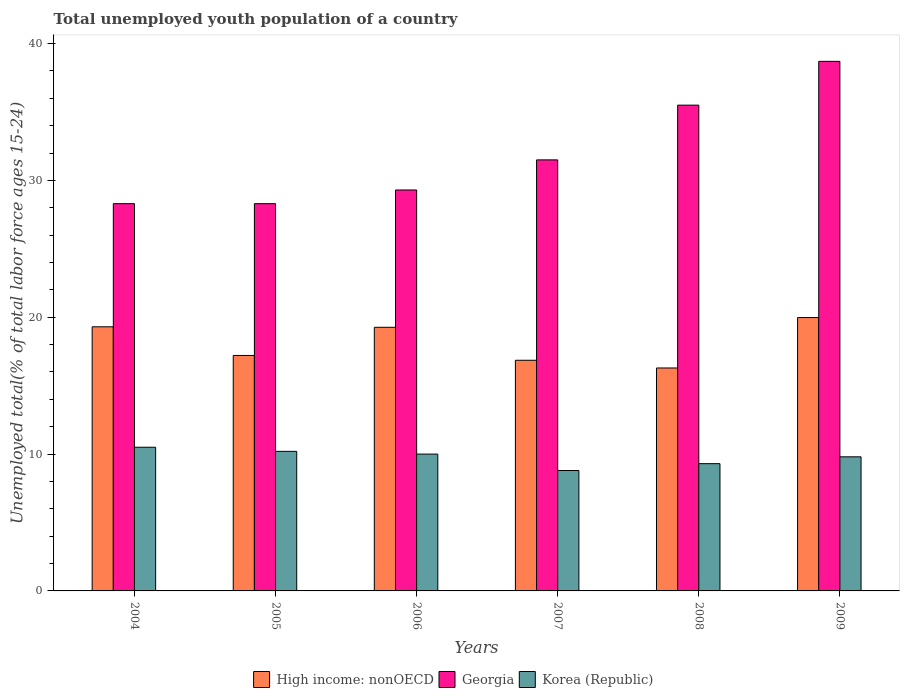How many different coloured bars are there?
Offer a terse response. 3. How many groups of bars are there?
Your response must be concise. 6. Are the number of bars on each tick of the X-axis equal?
Keep it short and to the point. Yes. How many bars are there on the 5th tick from the left?
Your response must be concise. 3. In how many cases, is the number of bars for a given year not equal to the number of legend labels?
Your answer should be compact. 0. What is the percentage of total unemployed youth population of a country in High income: nonOECD in 2007?
Your response must be concise. 16.86. Across all years, what is the maximum percentage of total unemployed youth population of a country in High income: nonOECD?
Ensure brevity in your answer.  19.98. Across all years, what is the minimum percentage of total unemployed youth population of a country in High income: nonOECD?
Provide a succinct answer. 16.29. In which year was the percentage of total unemployed youth population of a country in Korea (Republic) maximum?
Provide a short and direct response. 2004. In which year was the percentage of total unemployed youth population of a country in Korea (Republic) minimum?
Your answer should be compact. 2007. What is the total percentage of total unemployed youth population of a country in Georgia in the graph?
Keep it short and to the point. 191.6. What is the difference between the percentage of total unemployed youth population of a country in Korea (Republic) in 2006 and that in 2007?
Keep it short and to the point. 1.2. What is the difference between the percentage of total unemployed youth population of a country in Georgia in 2007 and the percentage of total unemployed youth population of a country in Korea (Republic) in 2008?
Your answer should be compact. 22.2. What is the average percentage of total unemployed youth population of a country in High income: nonOECD per year?
Your answer should be very brief. 18.15. In the year 2005, what is the difference between the percentage of total unemployed youth population of a country in Georgia and percentage of total unemployed youth population of a country in High income: nonOECD?
Keep it short and to the point. 11.09. In how many years, is the percentage of total unemployed youth population of a country in High income: nonOECD greater than 12 %?
Keep it short and to the point. 6. What is the ratio of the percentage of total unemployed youth population of a country in Korea (Republic) in 2004 to that in 2008?
Provide a succinct answer. 1.13. Is the percentage of total unemployed youth population of a country in Korea (Republic) in 2005 less than that in 2008?
Offer a very short reply. No. Is the difference between the percentage of total unemployed youth population of a country in Georgia in 2005 and 2006 greater than the difference between the percentage of total unemployed youth population of a country in High income: nonOECD in 2005 and 2006?
Your answer should be very brief. Yes. What is the difference between the highest and the second highest percentage of total unemployed youth population of a country in Korea (Republic)?
Your answer should be compact. 0.3. What is the difference between the highest and the lowest percentage of total unemployed youth population of a country in High income: nonOECD?
Ensure brevity in your answer.  3.69. Is the sum of the percentage of total unemployed youth population of a country in Korea (Republic) in 2005 and 2006 greater than the maximum percentage of total unemployed youth population of a country in High income: nonOECD across all years?
Give a very brief answer. Yes. What does the 3rd bar from the left in 2008 represents?
Provide a short and direct response. Korea (Republic). What does the 1st bar from the right in 2006 represents?
Keep it short and to the point. Korea (Republic). How many bars are there?
Ensure brevity in your answer.  18. Are all the bars in the graph horizontal?
Ensure brevity in your answer.  No. How many years are there in the graph?
Your answer should be compact. 6. Where does the legend appear in the graph?
Your answer should be compact. Bottom center. How many legend labels are there?
Give a very brief answer. 3. How are the legend labels stacked?
Offer a very short reply. Horizontal. What is the title of the graph?
Your answer should be compact. Total unemployed youth population of a country. What is the label or title of the X-axis?
Provide a succinct answer. Years. What is the label or title of the Y-axis?
Keep it short and to the point. Unemployed total(% of total labor force ages 15-24). What is the Unemployed total(% of total labor force ages 15-24) of High income: nonOECD in 2004?
Your answer should be compact. 19.3. What is the Unemployed total(% of total labor force ages 15-24) in Georgia in 2004?
Provide a succinct answer. 28.3. What is the Unemployed total(% of total labor force ages 15-24) in Korea (Republic) in 2004?
Offer a very short reply. 10.5. What is the Unemployed total(% of total labor force ages 15-24) in High income: nonOECD in 2005?
Provide a succinct answer. 17.21. What is the Unemployed total(% of total labor force ages 15-24) in Georgia in 2005?
Make the answer very short. 28.3. What is the Unemployed total(% of total labor force ages 15-24) of Korea (Republic) in 2005?
Make the answer very short. 10.2. What is the Unemployed total(% of total labor force ages 15-24) in High income: nonOECD in 2006?
Your answer should be compact. 19.27. What is the Unemployed total(% of total labor force ages 15-24) of Georgia in 2006?
Give a very brief answer. 29.3. What is the Unemployed total(% of total labor force ages 15-24) in Korea (Republic) in 2006?
Give a very brief answer. 10. What is the Unemployed total(% of total labor force ages 15-24) of High income: nonOECD in 2007?
Ensure brevity in your answer.  16.86. What is the Unemployed total(% of total labor force ages 15-24) in Georgia in 2007?
Keep it short and to the point. 31.5. What is the Unemployed total(% of total labor force ages 15-24) of Korea (Republic) in 2007?
Offer a terse response. 8.8. What is the Unemployed total(% of total labor force ages 15-24) of High income: nonOECD in 2008?
Offer a terse response. 16.29. What is the Unemployed total(% of total labor force ages 15-24) in Georgia in 2008?
Your answer should be very brief. 35.5. What is the Unemployed total(% of total labor force ages 15-24) of Korea (Republic) in 2008?
Make the answer very short. 9.3. What is the Unemployed total(% of total labor force ages 15-24) of High income: nonOECD in 2009?
Your answer should be compact. 19.98. What is the Unemployed total(% of total labor force ages 15-24) in Georgia in 2009?
Keep it short and to the point. 38.7. What is the Unemployed total(% of total labor force ages 15-24) of Korea (Republic) in 2009?
Offer a very short reply. 9.8. Across all years, what is the maximum Unemployed total(% of total labor force ages 15-24) in High income: nonOECD?
Offer a terse response. 19.98. Across all years, what is the maximum Unemployed total(% of total labor force ages 15-24) in Georgia?
Provide a succinct answer. 38.7. Across all years, what is the maximum Unemployed total(% of total labor force ages 15-24) in Korea (Republic)?
Keep it short and to the point. 10.5. Across all years, what is the minimum Unemployed total(% of total labor force ages 15-24) in High income: nonOECD?
Provide a succinct answer. 16.29. Across all years, what is the minimum Unemployed total(% of total labor force ages 15-24) in Georgia?
Your answer should be very brief. 28.3. Across all years, what is the minimum Unemployed total(% of total labor force ages 15-24) in Korea (Republic)?
Your answer should be very brief. 8.8. What is the total Unemployed total(% of total labor force ages 15-24) of High income: nonOECD in the graph?
Your answer should be very brief. 108.9. What is the total Unemployed total(% of total labor force ages 15-24) of Georgia in the graph?
Your response must be concise. 191.6. What is the total Unemployed total(% of total labor force ages 15-24) of Korea (Republic) in the graph?
Give a very brief answer. 58.6. What is the difference between the Unemployed total(% of total labor force ages 15-24) of High income: nonOECD in 2004 and that in 2005?
Offer a terse response. 2.09. What is the difference between the Unemployed total(% of total labor force ages 15-24) of Korea (Republic) in 2004 and that in 2005?
Provide a succinct answer. 0.3. What is the difference between the Unemployed total(% of total labor force ages 15-24) in High income: nonOECD in 2004 and that in 2006?
Provide a succinct answer. 0.04. What is the difference between the Unemployed total(% of total labor force ages 15-24) in Georgia in 2004 and that in 2006?
Keep it short and to the point. -1. What is the difference between the Unemployed total(% of total labor force ages 15-24) of High income: nonOECD in 2004 and that in 2007?
Give a very brief answer. 2.45. What is the difference between the Unemployed total(% of total labor force ages 15-24) in Georgia in 2004 and that in 2007?
Ensure brevity in your answer.  -3.2. What is the difference between the Unemployed total(% of total labor force ages 15-24) in Korea (Republic) in 2004 and that in 2007?
Give a very brief answer. 1.7. What is the difference between the Unemployed total(% of total labor force ages 15-24) in High income: nonOECD in 2004 and that in 2008?
Offer a terse response. 3.01. What is the difference between the Unemployed total(% of total labor force ages 15-24) in High income: nonOECD in 2004 and that in 2009?
Your answer should be very brief. -0.67. What is the difference between the Unemployed total(% of total labor force ages 15-24) in Georgia in 2004 and that in 2009?
Give a very brief answer. -10.4. What is the difference between the Unemployed total(% of total labor force ages 15-24) in High income: nonOECD in 2005 and that in 2006?
Provide a short and direct response. -2.06. What is the difference between the Unemployed total(% of total labor force ages 15-24) of High income: nonOECD in 2005 and that in 2007?
Ensure brevity in your answer.  0.35. What is the difference between the Unemployed total(% of total labor force ages 15-24) in High income: nonOECD in 2005 and that in 2008?
Your response must be concise. 0.92. What is the difference between the Unemployed total(% of total labor force ages 15-24) in Georgia in 2005 and that in 2008?
Your answer should be very brief. -7.2. What is the difference between the Unemployed total(% of total labor force ages 15-24) of Korea (Republic) in 2005 and that in 2008?
Your answer should be compact. 0.9. What is the difference between the Unemployed total(% of total labor force ages 15-24) in High income: nonOECD in 2005 and that in 2009?
Your answer should be compact. -2.77. What is the difference between the Unemployed total(% of total labor force ages 15-24) in Korea (Republic) in 2005 and that in 2009?
Ensure brevity in your answer.  0.4. What is the difference between the Unemployed total(% of total labor force ages 15-24) in High income: nonOECD in 2006 and that in 2007?
Your response must be concise. 2.41. What is the difference between the Unemployed total(% of total labor force ages 15-24) in Georgia in 2006 and that in 2007?
Keep it short and to the point. -2.2. What is the difference between the Unemployed total(% of total labor force ages 15-24) of Korea (Republic) in 2006 and that in 2007?
Offer a terse response. 1.2. What is the difference between the Unemployed total(% of total labor force ages 15-24) of High income: nonOECD in 2006 and that in 2008?
Keep it short and to the point. 2.97. What is the difference between the Unemployed total(% of total labor force ages 15-24) of Georgia in 2006 and that in 2008?
Your response must be concise. -6.2. What is the difference between the Unemployed total(% of total labor force ages 15-24) of High income: nonOECD in 2006 and that in 2009?
Provide a succinct answer. -0.71. What is the difference between the Unemployed total(% of total labor force ages 15-24) in Georgia in 2006 and that in 2009?
Provide a short and direct response. -9.4. What is the difference between the Unemployed total(% of total labor force ages 15-24) in High income: nonOECD in 2007 and that in 2008?
Ensure brevity in your answer.  0.56. What is the difference between the Unemployed total(% of total labor force ages 15-24) in Korea (Republic) in 2007 and that in 2008?
Your response must be concise. -0.5. What is the difference between the Unemployed total(% of total labor force ages 15-24) in High income: nonOECD in 2007 and that in 2009?
Keep it short and to the point. -3.12. What is the difference between the Unemployed total(% of total labor force ages 15-24) of High income: nonOECD in 2008 and that in 2009?
Your response must be concise. -3.69. What is the difference between the Unemployed total(% of total labor force ages 15-24) of Georgia in 2008 and that in 2009?
Offer a very short reply. -3.2. What is the difference between the Unemployed total(% of total labor force ages 15-24) in Korea (Republic) in 2008 and that in 2009?
Make the answer very short. -0.5. What is the difference between the Unemployed total(% of total labor force ages 15-24) in High income: nonOECD in 2004 and the Unemployed total(% of total labor force ages 15-24) in Georgia in 2005?
Offer a terse response. -9. What is the difference between the Unemployed total(% of total labor force ages 15-24) of High income: nonOECD in 2004 and the Unemployed total(% of total labor force ages 15-24) of Korea (Republic) in 2005?
Make the answer very short. 9.1. What is the difference between the Unemployed total(% of total labor force ages 15-24) in Georgia in 2004 and the Unemployed total(% of total labor force ages 15-24) in Korea (Republic) in 2005?
Ensure brevity in your answer.  18.1. What is the difference between the Unemployed total(% of total labor force ages 15-24) of High income: nonOECD in 2004 and the Unemployed total(% of total labor force ages 15-24) of Georgia in 2006?
Your answer should be compact. -10. What is the difference between the Unemployed total(% of total labor force ages 15-24) of High income: nonOECD in 2004 and the Unemployed total(% of total labor force ages 15-24) of Korea (Republic) in 2006?
Your answer should be compact. 9.3. What is the difference between the Unemployed total(% of total labor force ages 15-24) of High income: nonOECD in 2004 and the Unemployed total(% of total labor force ages 15-24) of Georgia in 2007?
Offer a very short reply. -12.2. What is the difference between the Unemployed total(% of total labor force ages 15-24) in High income: nonOECD in 2004 and the Unemployed total(% of total labor force ages 15-24) in Korea (Republic) in 2007?
Offer a very short reply. 10.5. What is the difference between the Unemployed total(% of total labor force ages 15-24) of Georgia in 2004 and the Unemployed total(% of total labor force ages 15-24) of Korea (Republic) in 2007?
Keep it short and to the point. 19.5. What is the difference between the Unemployed total(% of total labor force ages 15-24) of High income: nonOECD in 2004 and the Unemployed total(% of total labor force ages 15-24) of Georgia in 2008?
Your response must be concise. -16.2. What is the difference between the Unemployed total(% of total labor force ages 15-24) of High income: nonOECD in 2004 and the Unemployed total(% of total labor force ages 15-24) of Korea (Republic) in 2008?
Keep it short and to the point. 10. What is the difference between the Unemployed total(% of total labor force ages 15-24) in High income: nonOECD in 2004 and the Unemployed total(% of total labor force ages 15-24) in Georgia in 2009?
Your answer should be compact. -19.4. What is the difference between the Unemployed total(% of total labor force ages 15-24) of High income: nonOECD in 2004 and the Unemployed total(% of total labor force ages 15-24) of Korea (Republic) in 2009?
Your answer should be very brief. 9.5. What is the difference between the Unemployed total(% of total labor force ages 15-24) in High income: nonOECD in 2005 and the Unemployed total(% of total labor force ages 15-24) in Georgia in 2006?
Ensure brevity in your answer.  -12.09. What is the difference between the Unemployed total(% of total labor force ages 15-24) of High income: nonOECD in 2005 and the Unemployed total(% of total labor force ages 15-24) of Korea (Republic) in 2006?
Your answer should be very brief. 7.21. What is the difference between the Unemployed total(% of total labor force ages 15-24) in High income: nonOECD in 2005 and the Unemployed total(% of total labor force ages 15-24) in Georgia in 2007?
Your answer should be very brief. -14.29. What is the difference between the Unemployed total(% of total labor force ages 15-24) in High income: nonOECD in 2005 and the Unemployed total(% of total labor force ages 15-24) in Korea (Republic) in 2007?
Provide a succinct answer. 8.41. What is the difference between the Unemployed total(% of total labor force ages 15-24) in High income: nonOECD in 2005 and the Unemployed total(% of total labor force ages 15-24) in Georgia in 2008?
Your answer should be compact. -18.29. What is the difference between the Unemployed total(% of total labor force ages 15-24) of High income: nonOECD in 2005 and the Unemployed total(% of total labor force ages 15-24) of Korea (Republic) in 2008?
Keep it short and to the point. 7.91. What is the difference between the Unemployed total(% of total labor force ages 15-24) in Georgia in 2005 and the Unemployed total(% of total labor force ages 15-24) in Korea (Republic) in 2008?
Your response must be concise. 19. What is the difference between the Unemployed total(% of total labor force ages 15-24) in High income: nonOECD in 2005 and the Unemployed total(% of total labor force ages 15-24) in Georgia in 2009?
Offer a terse response. -21.49. What is the difference between the Unemployed total(% of total labor force ages 15-24) of High income: nonOECD in 2005 and the Unemployed total(% of total labor force ages 15-24) of Korea (Republic) in 2009?
Your answer should be compact. 7.41. What is the difference between the Unemployed total(% of total labor force ages 15-24) of Georgia in 2005 and the Unemployed total(% of total labor force ages 15-24) of Korea (Republic) in 2009?
Ensure brevity in your answer.  18.5. What is the difference between the Unemployed total(% of total labor force ages 15-24) in High income: nonOECD in 2006 and the Unemployed total(% of total labor force ages 15-24) in Georgia in 2007?
Your response must be concise. -12.23. What is the difference between the Unemployed total(% of total labor force ages 15-24) in High income: nonOECD in 2006 and the Unemployed total(% of total labor force ages 15-24) in Korea (Republic) in 2007?
Give a very brief answer. 10.47. What is the difference between the Unemployed total(% of total labor force ages 15-24) of High income: nonOECD in 2006 and the Unemployed total(% of total labor force ages 15-24) of Georgia in 2008?
Provide a short and direct response. -16.23. What is the difference between the Unemployed total(% of total labor force ages 15-24) in High income: nonOECD in 2006 and the Unemployed total(% of total labor force ages 15-24) in Korea (Republic) in 2008?
Your answer should be compact. 9.97. What is the difference between the Unemployed total(% of total labor force ages 15-24) of Georgia in 2006 and the Unemployed total(% of total labor force ages 15-24) of Korea (Republic) in 2008?
Keep it short and to the point. 20. What is the difference between the Unemployed total(% of total labor force ages 15-24) in High income: nonOECD in 2006 and the Unemployed total(% of total labor force ages 15-24) in Georgia in 2009?
Your response must be concise. -19.43. What is the difference between the Unemployed total(% of total labor force ages 15-24) of High income: nonOECD in 2006 and the Unemployed total(% of total labor force ages 15-24) of Korea (Republic) in 2009?
Provide a succinct answer. 9.47. What is the difference between the Unemployed total(% of total labor force ages 15-24) in Georgia in 2006 and the Unemployed total(% of total labor force ages 15-24) in Korea (Republic) in 2009?
Ensure brevity in your answer.  19.5. What is the difference between the Unemployed total(% of total labor force ages 15-24) of High income: nonOECD in 2007 and the Unemployed total(% of total labor force ages 15-24) of Georgia in 2008?
Provide a succinct answer. -18.64. What is the difference between the Unemployed total(% of total labor force ages 15-24) in High income: nonOECD in 2007 and the Unemployed total(% of total labor force ages 15-24) in Korea (Republic) in 2008?
Ensure brevity in your answer.  7.56. What is the difference between the Unemployed total(% of total labor force ages 15-24) of High income: nonOECD in 2007 and the Unemployed total(% of total labor force ages 15-24) of Georgia in 2009?
Make the answer very short. -21.84. What is the difference between the Unemployed total(% of total labor force ages 15-24) of High income: nonOECD in 2007 and the Unemployed total(% of total labor force ages 15-24) of Korea (Republic) in 2009?
Give a very brief answer. 7.06. What is the difference between the Unemployed total(% of total labor force ages 15-24) in Georgia in 2007 and the Unemployed total(% of total labor force ages 15-24) in Korea (Republic) in 2009?
Ensure brevity in your answer.  21.7. What is the difference between the Unemployed total(% of total labor force ages 15-24) of High income: nonOECD in 2008 and the Unemployed total(% of total labor force ages 15-24) of Georgia in 2009?
Offer a very short reply. -22.41. What is the difference between the Unemployed total(% of total labor force ages 15-24) in High income: nonOECD in 2008 and the Unemployed total(% of total labor force ages 15-24) in Korea (Republic) in 2009?
Your answer should be very brief. 6.49. What is the difference between the Unemployed total(% of total labor force ages 15-24) in Georgia in 2008 and the Unemployed total(% of total labor force ages 15-24) in Korea (Republic) in 2009?
Your answer should be compact. 25.7. What is the average Unemployed total(% of total labor force ages 15-24) in High income: nonOECD per year?
Keep it short and to the point. 18.15. What is the average Unemployed total(% of total labor force ages 15-24) of Georgia per year?
Provide a short and direct response. 31.93. What is the average Unemployed total(% of total labor force ages 15-24) in Korea (Republic) per year?
Your answer should be compact. 9.77. In the year 2004, what is the difference between the Unemployed total(% of total labor force ages 15-24) in High income: nonOECD and Unemployed total(% of total labor force ages 15-24) in Georgia?
Give a very brief answer. -9. In the year 2004, what is the difference between the Unemployed total(% of total labor force ages 15-24) in High income: nonOECD and Unemployed total(% of total labor force ages 15-24) in Korea (Republic)?
Make the answer very short. 8.8. In the year 2005, what is the difference between the Unemployed total(% of total labor force ages 15-24) in High income: nonOECD and Unemployed total(% of total labor force ages 15-24) in Georgia?
Provide a succinct answer. -11.09. In the year 2005, what is the difference between the Unemployed total(% of total labor force ages 15-24) in High income: nonOECD and Unemployed total(% of total labor force ages 15-24) in Korea (Republic)?
Your response must be concise. 7.01. In the year 2006, what is the difference between the Unemployed total(% of total labor force ages 15-24) of High income: nonOECD and Unemployed total(% of total labor force ages 15-24) of Georgia?
Your answer should be very brief. -10.03. In the year 2006, what is the difference between the Unemployed total(% of total labor force ages 15-24) in High income: nonOECD and Unemployed total(% of total labor force ages 15-24) in Korea (Republic)?
Provide a short and direct response. 9.27. In the year 2006, what is the difference between the Unemployed total(% of total labor force ages 15-24) of Georgia and Unemployed total(% of total labor force ages 15-24) of Korea (Republic)?
Provide a succinct answer. 19.3. In the year 2007, what is the difference between the Unemployed total(% of total labor force ages 15-24) of High income: nonOECD and Unemployed total(% of total labor force ages 15-24) of Georgia?
Offer a very short reply. -14.64. In the year 2007, what is the difference between the Unemployed total(% of total labor force ages 15-24) in High income: nonOECD and Unemployed total(% of total labor force ages 15-24) in Korea (Republic)?
Your response must be concise. 8.06. In the year 2007, what is the difference between the Unemployed total(% of total labor force ages 15-24) in Georgia and Unemployed total(% of total labor force ages 15-24) in Korea (Republic)?
Ensure brevity in your answer.  22.7. In the year 2008, what is the difference between the Unemployed total(% of total labor force ages 15-24) of High income: nonOECD and Unemployed total(% of total labor force ages 15-24) of Georgia?
Provide a short and direct response. -19.21. In the year 2008, what is the difference between the Unemployed total(% of total labor force ages 15-24) of High income: nonOECD and Unemployed total(% of total labor force ages 15-24) of Korea (Republic)?
Keep it short and to the point. 6.99. In the year 2008, what is the difference between the Unemployed total(% of total labor force ages 15-24) of Georgia and Unemployed total(% of total labor force ages 15-24) of Korea (Republic)?
Your answer should be compact. 26.2. In the year 2009, what is the difference between the Unemployed total(% of total labor force ages 15-24) in High income: nonOECD and Unemployed total(% of total labor force ages 15-24) in Georgia?
Make the answer very short. -18.72. In the year 2009, what is the difference between the Unemployed total(% of total labor force ages 15-24) in High income: nonOECD and Unemployed total(% of total labor force ages 15-24) in Korea (Republic)?
Offer a very short reply. 10.18. In the year 2009, what is the difference between the Unemployed total(% of total labor force ages 15-24) in Georgia and Unemployed total(% of total labor force ages 15-24) in Korea (Republic)?
Ensure brevity in your answer.  28.9. What is the ratio of the Unemployed total(% of total labor force ages 15-24) of High income: nonOECD in 2004 to that in 2005?
Your answer should be very brief. 1.12. What is the ratio of the Unemployed total(% of total labor force ages 15-24) of Korea (Republic) in 2004 to that in 2005?
Provide a short and direct response. 1.03. What is the ratio of the Unemployed total(% of total labor force ages 15-24) of High income: nonOECD in 2004 to that in 2006?
Provide a succinct answer. 1. What is the ratio of the Unemployed total(% of total labor force ages 15-24) of Georgia in 2004 to that in 2006?
Your answer should be compact. 0.97. What is the ratio of the Unemployed total(% of total labor force ages 15-24) of Korea (Republic) in 2004 to that in 2006?
Keep it short and to the point. 1.05. What is the ratio of the Unemployed total(% of total labor force ages 15-24) of High income: nonOECD in 2004 to that in 2007?
Give a very brief answer. 1.15. What is the ratio of the Unemployed total(% of total labor force ages 15-24) in Georgia in 2004 to that in 2007?
Your answer should be very brief. 0.9. What is the ratio of the Unemployed total(% of total labor force ages 15-24) in Korea (Republic) in 2004 to that in 2007?
Your response must be concise. 1.19. What is the ratio of the Unemployed total(% of total labor force ages 15-24) in High income: nonOECD in 2004 to that in 2008?
Provide a short and direct response. 1.18. What is the ratio of the Unemployed total(% of total labor force ages 15-24) of Georgia in 2004 to that in 2008?
Offer a very short reply. 0.8. What is the ratio of the Unemployed total(% of total labor force ages 15-24) of Korea (Republic) in 2004 to that in 2008?
Provide a succinct answer. 1.13. What is the ratio of the Unemployed total(% of total labor force ages 15-24) in High income: nonOECD in 2004 to that in 2009?
Your answer should be very brief. 0.97. What is the ratio of the Unemployed total(% of total labor force ages 15-24) in Georgia in 2004 to that in 2009?
Keep it short and to the point. 0.73. What is the ratio of the Unemployed total(% of total labor force ages 15-24) of Korea (Republic) in 2004 to that in 2009?
Your answer should be compact. 1.07. What is the ratio of the Unemployed total(% of total labor force ages 15-24) of High income: nonOECD in 2005 to that in 2006?
Offer a terse response. 0.89. What is the ratio of the Unemployed total(% of total labor force ages 15-24) in Georgia in 2005 to that in 2006?
Offer a very short reply. 0.97. What is the ratio of the Unemployed total(% of total labor force ages 15-24) in High income: nonOECD in 2005 to that in 2007?
Your response must be concise. 1.02. What is the ratio of the Unemployed total(% of total labor force ages 15-24) in Georgia in 2005 to that in 2007?
Your answer should be compact. 0.9. What is the ratio of the Unemployed total(% of total labor force ages 15-24) in Korea (Republic) in 2005 to that in 2007?
Offer a terse response. 1.16. What is the ratio of the Unemployed total(% of total labor force ages 15-24) of High income: nonOECD in 2005 to that in 2008?
Offer a very short reply. 1.06. What is the ratio of the Unemployed total(% of total labor force ages 15-24) in Georgia in 2005 to that in 2008?
Provide a short and direct response. 0.8. What is the ratio of the Unemployed total(% of total labor force ages 15-24) in Korea (Republic) in 2005 to that in 2008?
Your answer should be compact. 1.1. What is the ratio of the Unemployed total(% of total labor force ages 15-24) in High income: nonOECD in 2005 to that in 2009?
Your answer should be compact. 0.86. What is the ratio of the Unemployed total(% of total labor force ages 15-24) in Georgia in 2005 to that in 2009?
Your answer should be compact. 0.73. What is the ratio of the Unemployed total(% of total labor force ages 15-24) of Korea (Republic) in 2005 to that in 2009?
Provide a short and direct response. 1.04. What is the ratio of the Unemployed total(% of total labor force ages 15-24) in High income: nonOECD in 2006 to that in 2007?
Provide a short and direct response. 1.14. What is the ratio of the Unemployed total(% of total labor force ages 15-24) of Georgia in 2006 to that in 2007?
Provide a short and direct response. 0.93. What is the ratio of the Unemployed total(% of total labor force ages 15-24) in Korea (Republic) in 2006 to that in 2007?
Your answer should be very brief. 1.14. What is the ratio of the Unemployed total(% of total labor force ages 15-24) in High income: nonOECD in 2006 to that in 2008?
Keep it short and to the point. 1.18. What is the ratio of the Unemployed total(% of total labor force ages 15-24) of Georgia in 2006 to that in 2008?
Ensure brevity in your answer.  0.83. What is the ratio of the Unemployed total(% of total labor force ages 15-24) of Korea (Republic) in 2006 to that in 2008?
Offer a terse response. 1.08. What is the ratio of the Unemployed total(% of total labor force ages 15-24) in High income: nonOECD in 2006 to that in 2009?
Your response must be concise. 0.96. What is the ratio of the Unemployed total(% of total labor force ages 15-24) of Georgia in 2006 to that in 2009?
Ensure brevity in your answer.  0.76. What is the ratio of the Unemployed total(% of total labor force ages 15-24) of Korea (Republic) in 2006 to that in 2009?
Give a very brief answer. 1.02. What is the ratio of the Unemployed total(% of total labor force ages 15-24) in High income: nonOECD in 2007 to that in 2008?
Your answer should be compact. 1.03. What is the ratio of the Unemployed total(% of total labor force ages 15-24) of Georgia in 2007 to that in 2008?
Offer a terse response. 0.89. What is the ratio of the Unemployed total(% of total labor force ages 15-24) in Korea (Republic) in 2007 to that in 2008?
Ensure brevity in your answer.  0.95. What is the ratio of the Unemployed total(% of total labor force ages 15-24) of High income: nonOECD in 2007 to that in 2009?
Your answer should be very brief. 0.84. What is the ratio of the Unemployed total(% of total labor force ages 15-24) in Georgia in 2007 to that in 2009?
Your response must be concise. 0.81. What is the ratio of the Unemployed total(% of total labor force ages 15-24) of Korea (Republic) in 2007 to that in 2009?
Your answer should be compact. 0.9. What is the ratio of the Unemployed total(% of total labor force ages 15-24) of High income: nonOECD in 2008 to that in 2009?
Provide a succinct answer. 0.82. What is the ratio of the Unemployed total(% of total labor force ages 15-24) of Georgia in 2008 to that in 2009?
Your answer should be very brief. 0.92. What is the ratio of the Unemployed total(% of total labor force ages 15-24) in Korea (Republic) in 2008 to that in 2009?
Give a very brief answer. 0.95. What is the difference between the highest and the second highest Unemployed total(% of total labor force ages 15-24) in High income: nonOECD?
Offer a terse response. 0.67. What is the difference between the highest and the lowest Unemployed total(% of total labor force ages 15-24) in High income: nonOECD?
Ensure brevity in your answer.  3.69. What is the difference between the highest and the lowest Unemployed total(% of total labor force ages 15-24) of Georgia?
Keep it short and to the point. 10.4. 